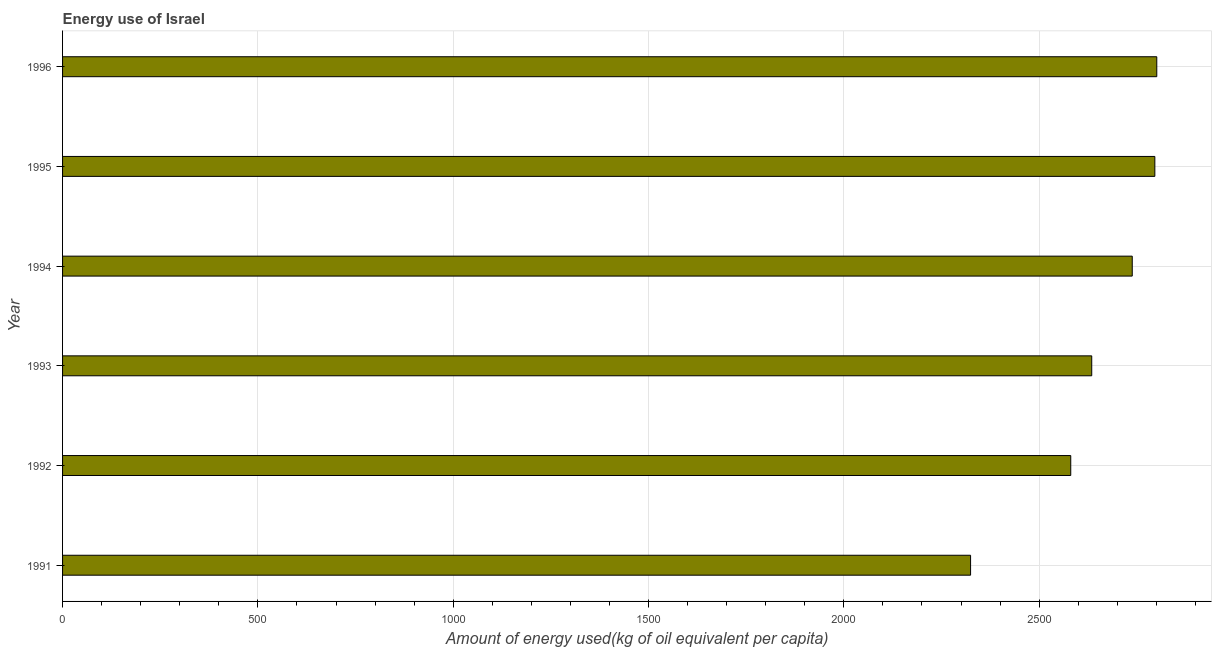Does the graph contain grids?
Provide a short and direct response. Yes. What is the title of the graph?
Your response must be concise. Energy use of Israel. What is the label or title of the X-axis?
Offer a terse response. Amount of energy used(kg of oil equivalent per capita). What is the amount of energy used in 1993?
Your response must be concise. 2634.67. Across all years, what is the maximum amount of energy used?
Provide a succinct answer. 2801.21. Across all years, what is the minimum amount of energy used?
Your answer should be compact. 2324.54. In which year was the amount of energy used maximum?
Provide a succinct answer. 1996. In which year was the amount of energy used minimum?
Keep it short and to the point. 1991. What is the sum of the amount of energy used?
Keep it short and to the point. 1.59e+04. What is the difference between the amount of energy used in 1991 and 1994?
Keep it short and to the point. -413.86. What is the average amount of energy used per year?
Keep it short and to the point. 2646.01. What is the median amount of energy used?
Keep it short and to the point. 2686.54. In how many years, is the amount of energy used greater than 700 kg?
Give a very brief answer. 6. Do a majority of the years between 1995 and 1996 (inclusive) have amount of energy used greater than 700 kg?
Make the answer very short. Yes. What is the ratio of the amount of energy used in 1991 to that in 1993?
Offer a very short reply. 0.88. Is the amount of energy used in 1994 less than that in 1996?
Keep it short and to the point. Yes. Is the difference between the amount of energy used in 1993 and 1995 greater than the difference between any two years?
Your answer should be very brief. No. What is the difference between the highest and the second highest amount of energy used?
Provide a succinct answer. 4.96. Is the sum of the amount of energy used in 1993 and 1995 greater than the maximum amount of energy used across all years?
Offer a very short reply. Yes. What is the difference between the highest and the lowest amount of energy used?
Your response must be concise. 476.67. How many years are there in the graph?
Offer a very short reply. 6. Are the values on the major ticks of X-axis written in scientific E-notation?
Your response must be concise. No. What is the Amount of energy used(kg of oil equivalent per capita) in 1991?
Offer a terse response. 2324.54. What is the Amount of energy used(kg of oil equivalent per capita) in 1992?
Offer a very short reply. 2580.97. What is the Amount of energy used(kg of oil equivalent per capita) of 1993?
Offer a very short reply. 2634.67. What is the Amount of energy used(kg of oil equivalent per capita) of 1994?
Ensure brevity in your answer.  2738.4. What is the Amount of energy used(kg of oil equivalent per capita) in 1995?
Your answer should be compact. 2796.25. What is the Amount of energy used(kg of oil equivalent per capita) of 1996?
Your answer should be compact. 2801.21. What is the difference between the Amount of energy used(kg of oil equivalent per capita) in 1991 and 1992?
Offer a terse response. -256.43. What is the difference between the Amount of energy used(kg of oil equivalent per capita) in 1991 and 1993?
Your response must be concise. -310.13. What is the difference between the Amount of energy used(kg of oil equivalent per capita) in 1991 and 1994?
Your response must be concise. -413.86. What is the difference between the Amount of energy used(kg of oil equivalent per capita) in 1991 and 1995?
Ensure brevity in your answer.  -471.71. What is the difference between the Amount of energy used(kg of oil equivalent per capita) in 1991 and 1996?
Provide a short and direct response. -476.67. What is the difference between the Amount of energy used(kg of oil equivalent per capita) in 1992 and 1993?
Your answer should be compact. -53.7. What is the difference between the Amount of energy used(kg of oil equivalent per capita) in 1992 and 1994?
Keep it short and to the point. -157.43. What is the difference between the Amount of energy used(kg of oil equivalent per capita) in 1992 and 1995?
Provide a succinct answer. -215.28. What is the difference between the Amount of energy used(kg of oil equivalent per capita) in 1992 and 1996?
Your answer should be very brief. -220.24. What is the difference between the Amount of energy used(kg of oil equivalent per capita) in 1993 and 1994?
Offer a very short reply. -103.73. What is the difference between the Amount of energy used(kg of oil equivalent per capita) in 1993 and 1995?
Provide a short and direct response. -161.58. What is the difference between the Amount of energy used(kg of oil equivalent per capita) in 1993 and 1996?
Ensure brevity in your answer.  -166.53. What is the difference between the Amount of energy used(kg of oil equivalent per capita) in 1994 and 1995?
Ensure brevity in your answer.  -57.85. What is the difference between the Amount of energy used(kg of oil equivalent per capita) in 1994 and 1996?
Your answer should be compact. -62.81. What is the difference between the Amount of energy used(kg of oil equivalent per capita) in 1995 and 1996?
Ensure brevity in your answer.  -4.96. What is the ratio of the Amount of energy used(kg of oil equivalent per capita) in 1991 to that in 1992?
Give a very brief answer. 0.9. What is the ratio of the Amount of energy used(kg of oil equivalent per capita) in 1991 to that in 1993?
Give a very brief answer. 0.88. What is the ratio of the Amount of energy used(kg of oil equivalent per capita) in 1991 to that in 1994?
Offer a very short reply. 0.85. What is the ratio of the Amount of energy used(kg of oil equivalent per capita) in 1991 to that in 1995?
Offer a very short reply. 0.83. What is the ratio of the Amount of energy used(kg of oil equivalent per capita) in 1991 to that in 1996?
Provide a succinct answer. 0.83. What is the ratio of the Amount of energy used(kg of oil equivalent per capita) in 1992 to that in 1993?
Keep it short and to the point. 0.98. What is the ratio of the Amount of energy used(kg of oil equivalent per capita) in 1992 to that in 1994?
Provide a succinct answer. 0.94. What is the ratio of the Amount of energy used(kg of oil equivalent per capita) in 1992 to that in 1995?
Make the answer very short. 0.92. What is the ratio of the Amount of energy used(kg of oil equivalent per capita) in 1992 to that in 1996?
Offer a terse response. 0.92. What is the ratio of the Amount of energy used(kg of oil equivalent per capita) in 1993 to that in 1995?
Your answer should be compact. 0.94. What is the ratio of the Amount of energy used(kg of oil equivalent per capita) in 1993 to that in 1996?
Make the answer very short. 0.94. What is the ratio of the Amount of energy used(kg of oil equivalent per capita) in 1994 to that in 1995?
Make the answer very short. 0.98. What is the ratio of the Amount of energy used(kg of oil equivalent per capita) in 1995 to that in 1996?
Give a very brief answer. 1. 